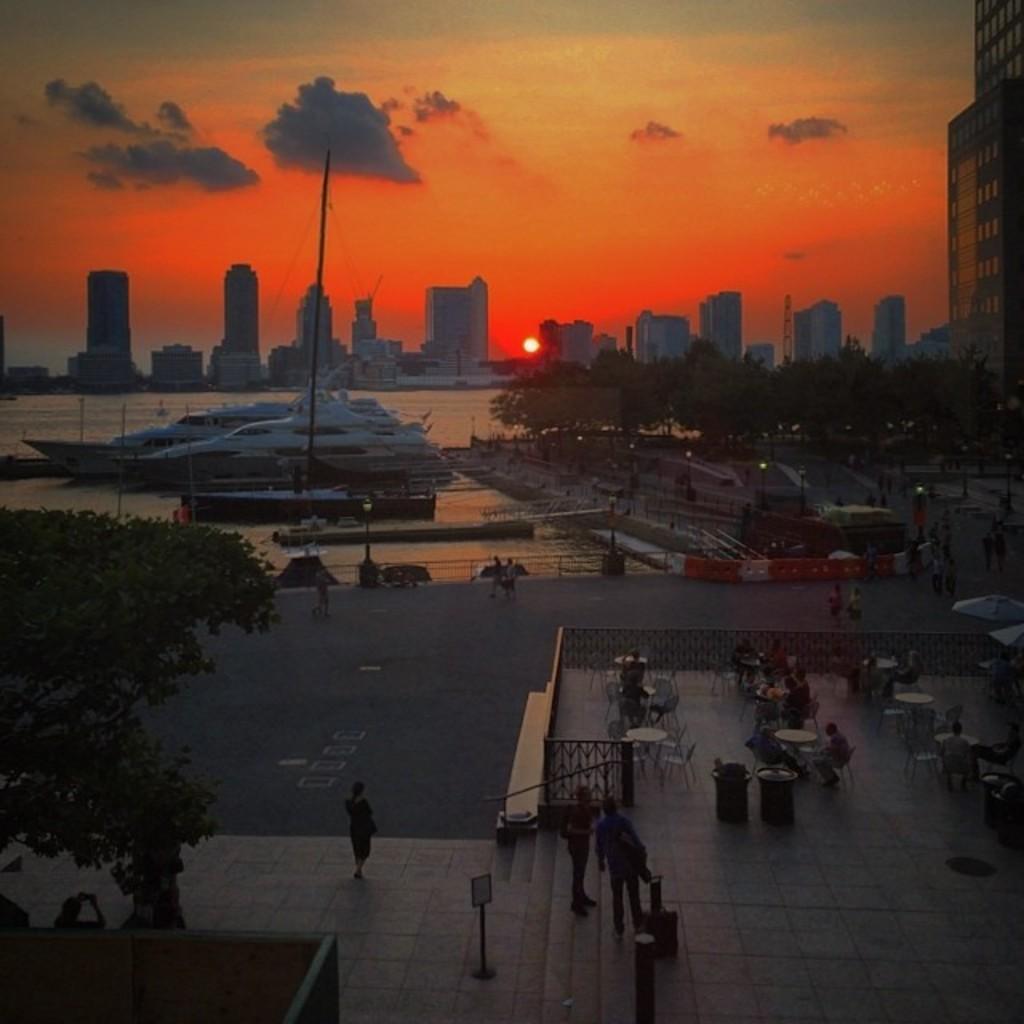In one or two sentences, can you explain what this image depicts? In this picture I can see at right side there are few people sitting and they have tables in front of them and in the backdrop there are trees, buildings and there is a sea with few boats sailing on the water and the sky is clear with sunset. 